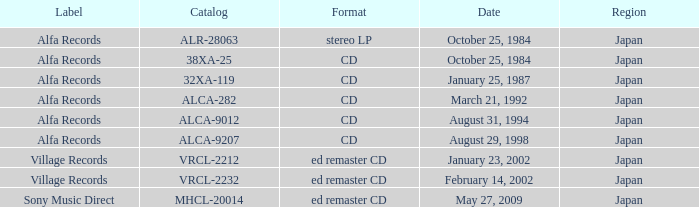What Label released on October 25, 1984, in the format of Stereo LP? Alfa Records. 